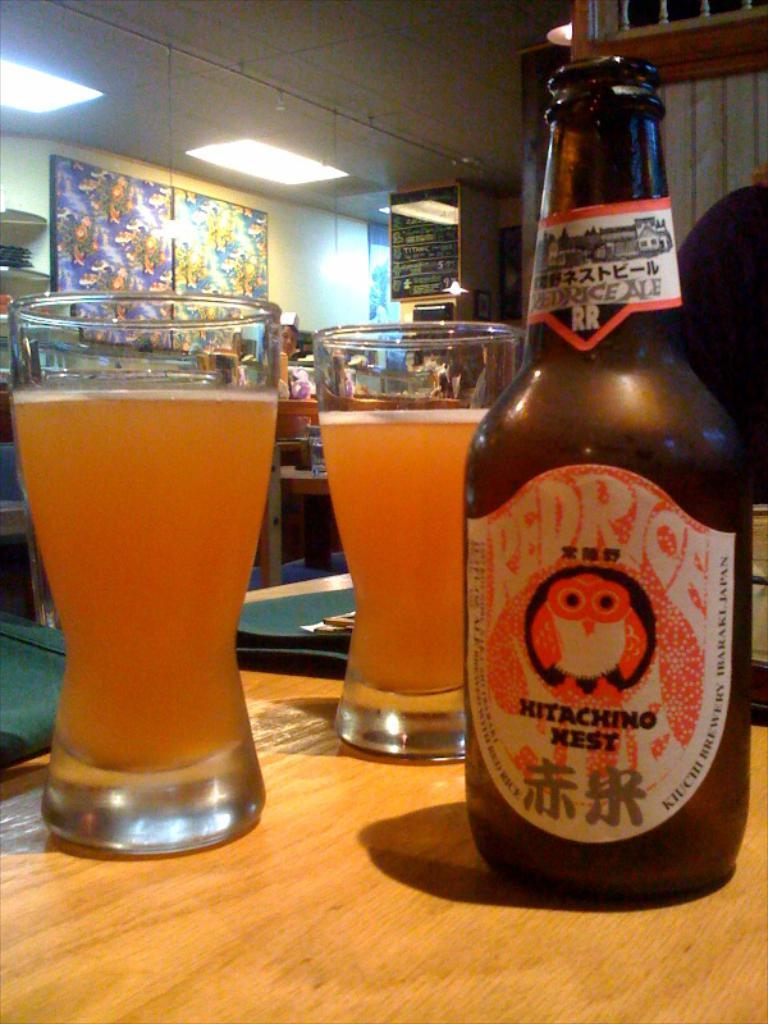<image>
Present a compact description of the photo's key features. Two full beer glasses are near a bottle of REDRICE on a wooden table. 